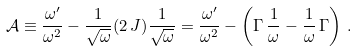Convert formula to latex. <formula><loc_0><loc_0><loc_500><loc_500>\mathcal { A } \equiv \frac { \omega ^ { \prime } } { \omega ^ { 2 } } - \frac { 1 } { \sqrt { \omega } } ( 2 \, J ) \frac { 1 } { \sqrt { \omega } } = \frac { \omega ^ { \prime } } { \omega ^ { 2 } } - \left ( \Gamma \, \frac { 1 } { \omega } - \frac { 1 } { \omega } \, \Gamma \right ) \, .</formula> 